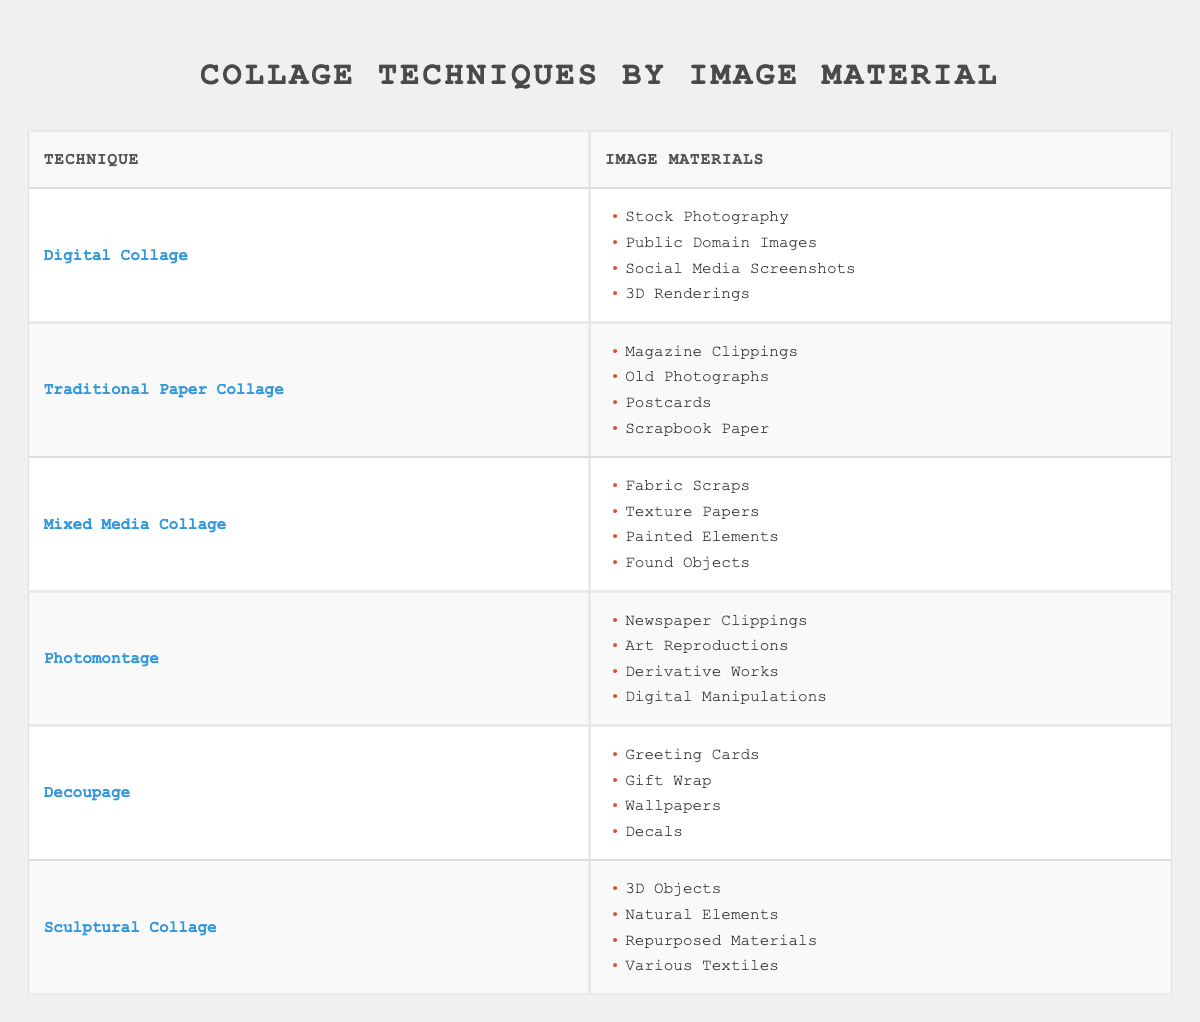What technique uses stock photography? By scanning the first row of the table, we see that "Digital Collage" is listed alongside stock photography in the corresponding column.
Answer: Digital Collage Which image material is associated with traditional paper collage? In the second row, "Traditional Paper Collage" corresponds to magazine clippings, old photographs, postcards, and scrapbook paper. Therefore, these are the materials associated with this technique.
Answer: Magazine Clippings, Old Photographs, Postcards, Scrapbook Paper Are fabric scraps used in digital collage? Referring to the fourth row of the table, fabric scraps are listed under "Mixed Media Collage," not "Digital Collage." Thus, the answer is no.
Answer: No What materials are used in photomontage? The fourth row directly provides "Newspaper Clippings," "Art Reproductions," "Derivative Works," and "Digital Manipulations" as materials used in photomontage.
Answer: Newspaper Clippings, Art Reproductions, Derivative Works, Digital Manipulations How many types of collage techniques use paper materials? The techniques related to paper materials are "Traditional Paper Collage" and "Decoupage." Counting these yields a total of two techniques.
Answer: 2 Which technique uses 3D objects as material? Looking at the last row of the table, "Sculptural Collage" includes 3D objects in its listed image materials.
Answer: Sculptural Collage Is there any technique that employs found objects? Throughout the table, examining all techniques, only "Mixed Media Collage" lists found objects as a material. So, the answer is yes.
Answer: Yes What is the primary difference between digital collage and traditional paper collage in terms of image materials? The materials for "Digital Collage" include stock photography and social media screenshots, while "Traditional Paper Collage" utilizes magazine clippings and old photographs. The difference lies in the digital versus tactile foundations of the materials.
Answer: Digital materials vs. printed materials Which technique includes natural elements as part of its materials? In the last row associated with "Sculptural Collage," natural elements are explicitly mentioned as one of the materials.
Answer: Sculptural Collage 